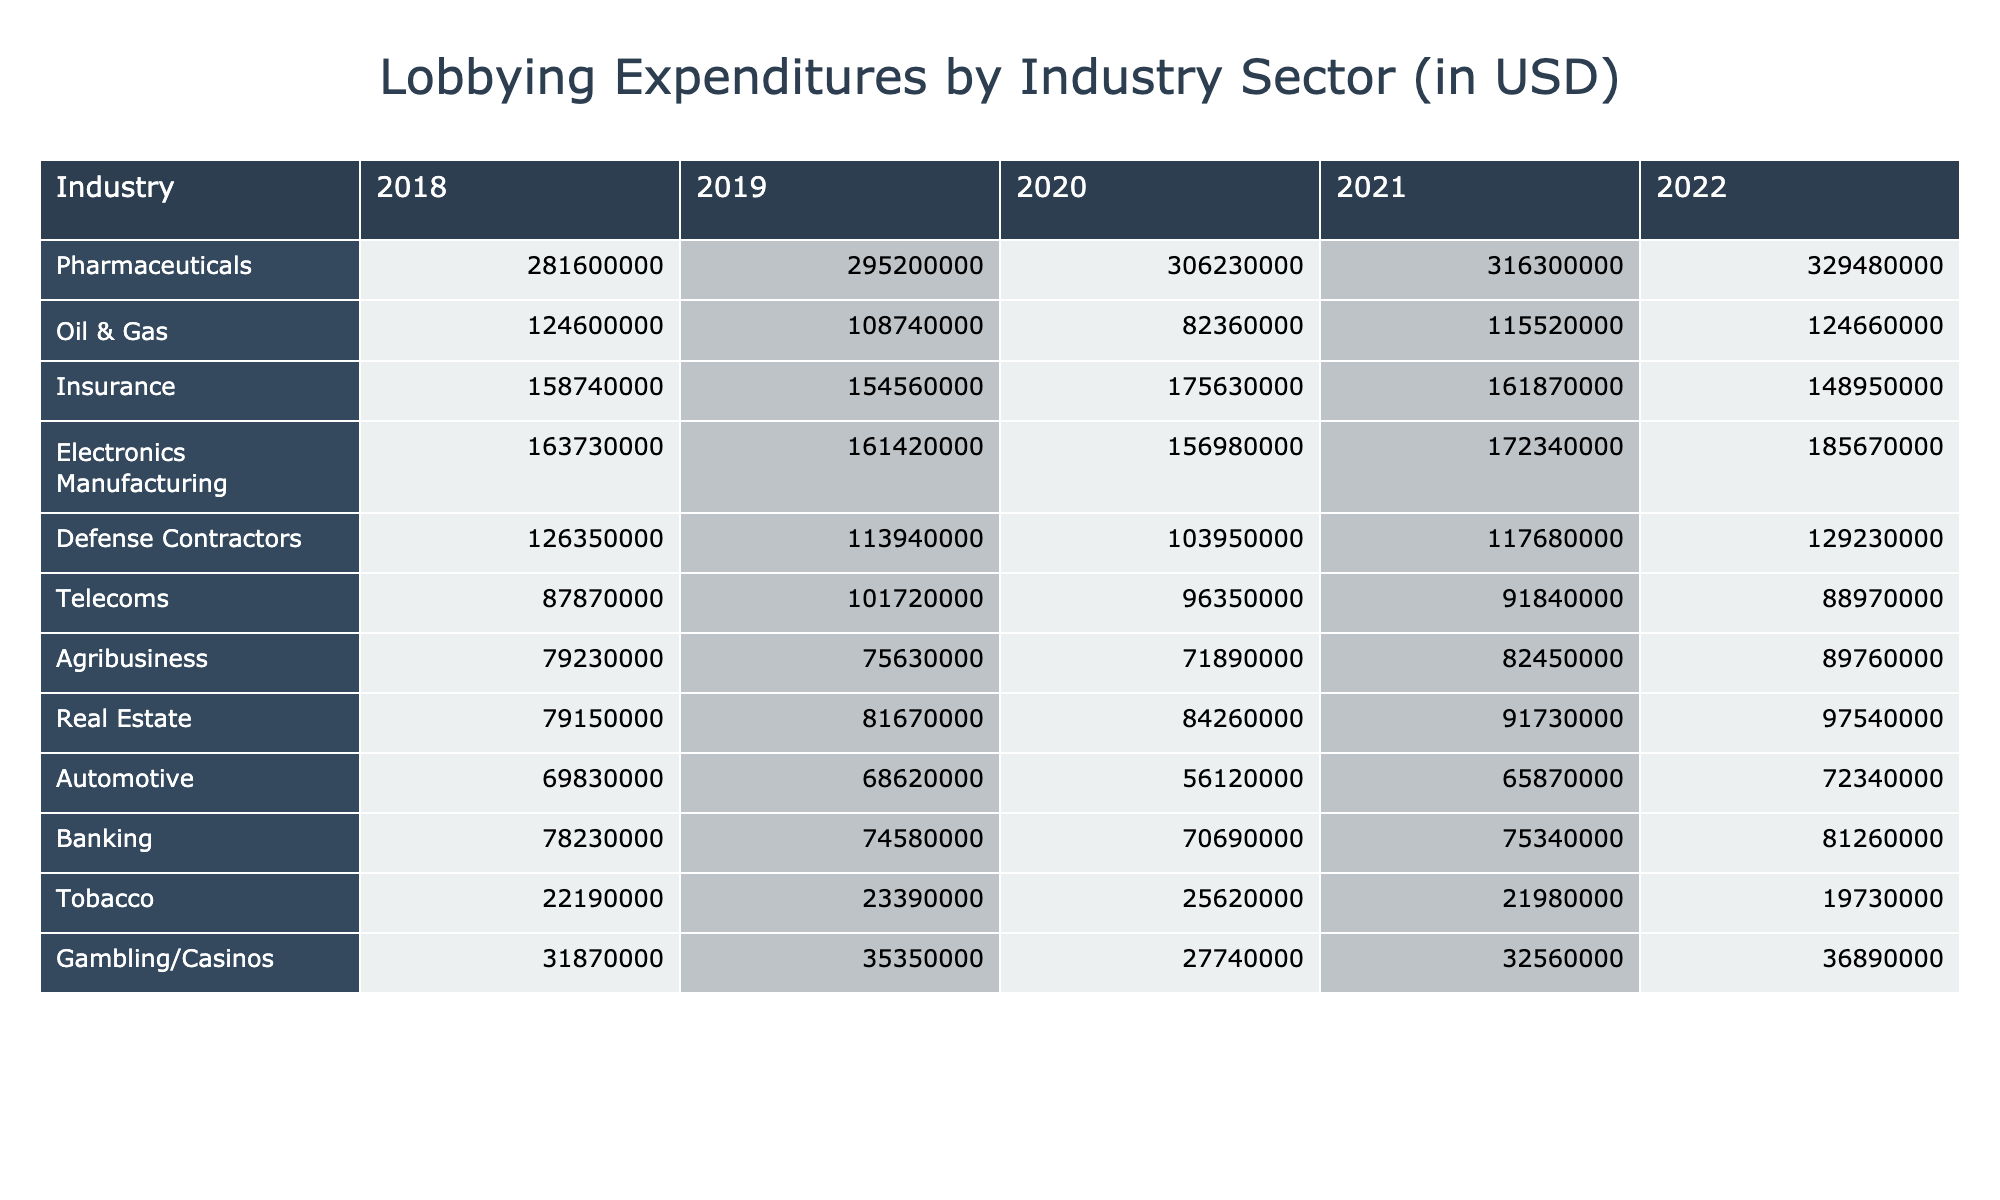What's the lobbying expenditure for Pharmaceuticals in 2022? In the table, looking at the Pharmaceuticals row, the value for the year 2022 is given as 329,480,000.
Answer: 329480000 Which industry spent the least on lobbying in 2019? In the 2019 column, the values for each industry are listed. By comparing them, the industry with the lowest expenditure is Tobacco at 23,390,000.
Answer: Tobacco What is the sum of lobbying expenditures for Oil & Gas from 2018 to 2022? To find the sum, we add the values for Oil & Gas across the years: 124,600,000 (2018) + 108,740,000 (2019) + 82,360,000 (2020) + 115,520,000 (2021) + 124,660,000 (2022) = 555,880,000.
Answer: 555880000 Did the Real Estate sector's lobbying expenditure increase or decrease from 2018 to 2022? By comparing the values, Real Estate had 79,150,000 in 2018 and 97,540,000 in 2022. Since 97,540,000 is greater than 79,150,000, the expenditure increased.
Answer: Increase What was the average yearly lobbying expenditure for the Tobacco industry from 2018 to 2022? The values for Tobacco are: 22,190,000 (2018), 23,390,000 (2019), 25,620,000 (2020), 21,980,000 (2021), and 19,730,000 (2022). Summing these gives 112,910,000. Dividing by 5 (the number of years) results in an average of 22,582,000.
Answer: 22582000 Which industry had the highest total lobbying expenditure over the five years? Calculating the total for each industry, Pharmaceuticals had the highest with 1,475,760,000.
Answer: Pharmaceuticals Was there a decline in lobbying expenditures for the Defense Contractors from 2018 to 2020? The values for Defense Contractors are: 126,350,000 (2018), 113,940,000 (2019), and 103,950,000 (2020). Since the values decreased each year, there was indeed a decline.
Answer: Yes What is the difference between the highest and lowest expenditures in 2021? The highest expenditure in 2021 is Pharmaceuticals at 316,300,000 and the lowest is Tobacco at 21,980,000. The difference is 316,300,000 - 21,980,000 = 294,320,000.
Answer: 294320000 What was the trend in lobbying expenditures for Telecoms from 2018 to 2022? The expenditures for Telecoms are 87,870,000 (2018), 101,720,000 (2019), 96,350,000 (2020), 91,840,000 (2021), and 88,970,000 (2022). The trend shows an initial increase in 2019, but then a decline in the following years.
Answer: Decline after initial increase How much more did the Electronics Manufacturing sector spend on lobbying in 2022 compared to 2018? Electronics Manufacturing spent 185,670,000 in 2022 and 163,730,000 in 2018. The difference is 185,670,000 - 163,730,000 = 21,940,000.
Answer: 21940000 